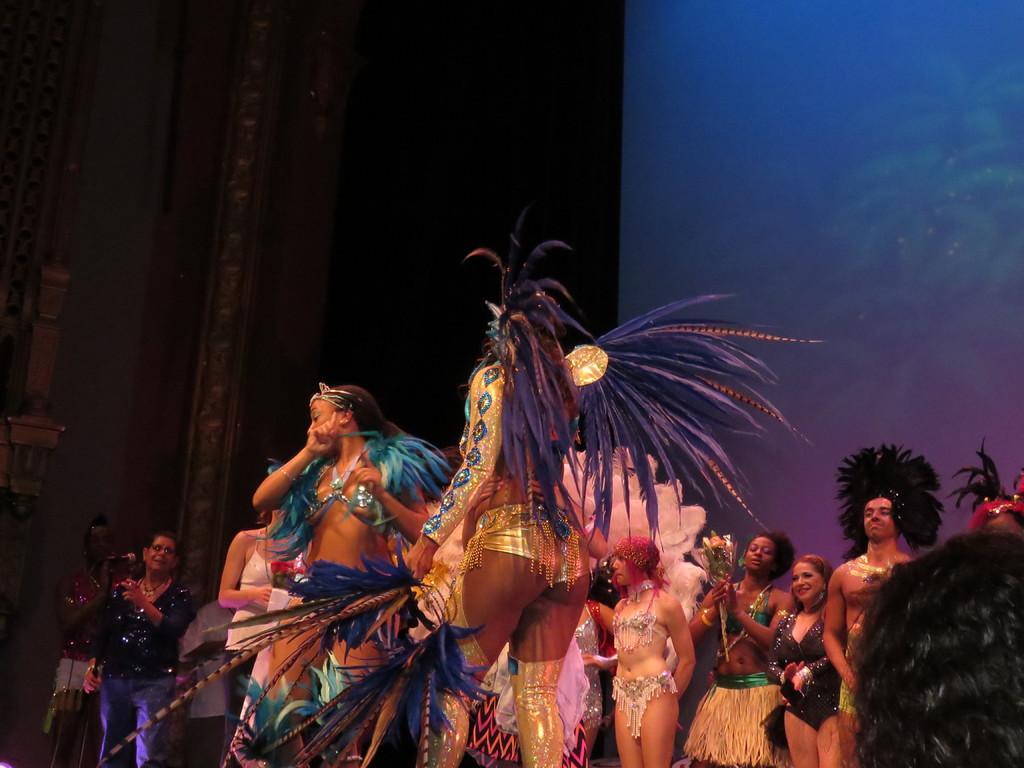Could you give a brief overview of what you see in this image? In this picture there is a group of girls wearing fancy dresses and dancing on the stage. Behind we can see a black curtain and a blue wall. 